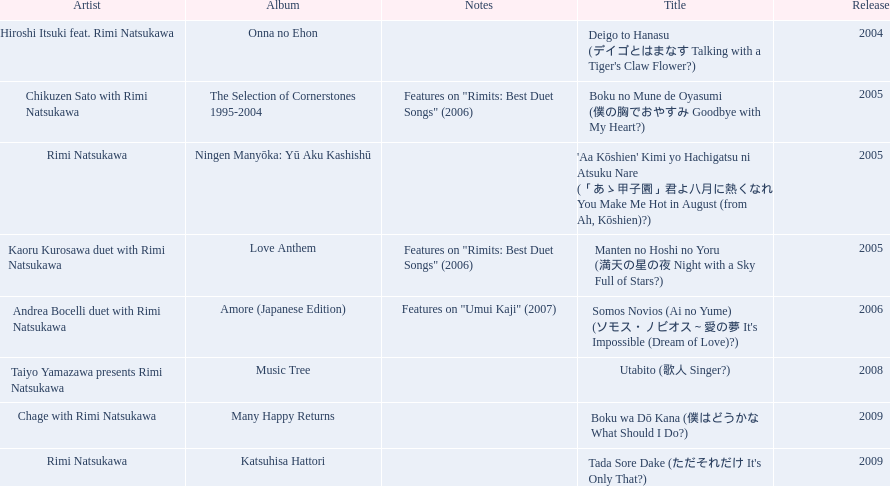What are the names of each album by rimi natsukawa? Onna no Ehon, The Selection of Cornerstones 1995-2004, Ningen Manyōka: Yū Aku Kashishū, Love Anthem, Amore (Japanese Edition), Music Tree, Many Happy Returns, Katsuhisa Hattori. And when were the albums released? 2004, 2005, 2005, 2005, 2006, 2008, 2009, 2009. Was onna no ehon or music tree released most recently? Music Tree. 